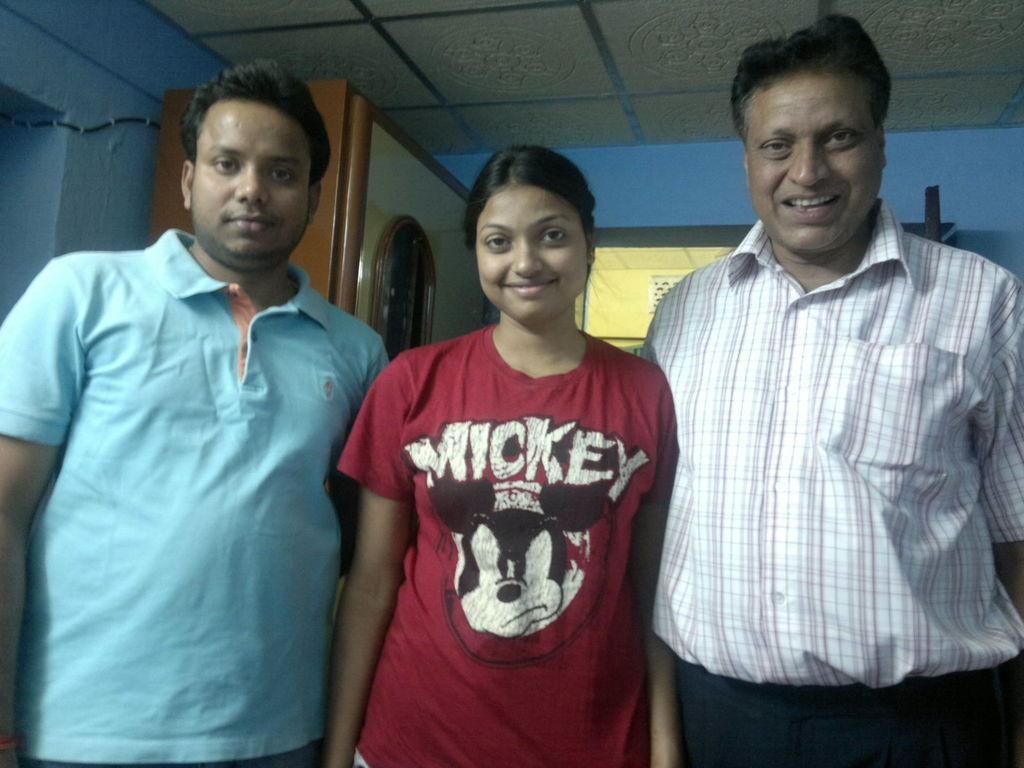How many people are in the image? There are three people in the image. Can you describe the gender of the people in the image? Two of the people are men, and one is a woman. What are the people in the image doing? The people are standing and posing for a photo. Where was the photo taken? The photo was taken in a room. What can be seen in the background of the image? There is a cabinet in the background of the image, and a blue color wall is beside the cabinet. What type of sofa can be seen in the image? There is no sofa present in the image. How does the woman blow a bubble in the image? The woman does not blow a bubble in the image; she is standing and posing for a photo. 